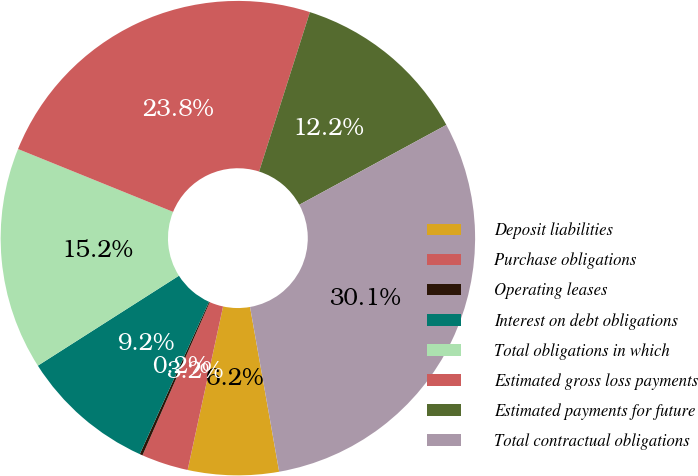Convert chart to OTSL. <chart><loc_0><loc_0><loc_500><loc_500><pie_chart><fcel>Deposit liabilities<fcel>Purchase obligations<fcel>Operating leases<fcel>Interest on debt obligations<fcel>Total obligations in which<fcel>Estimated gross loss payments<fcel>Estimated payments for future<fcel>Total contractual obligations<nl><fcel>6.18%<fcel>3.19%<fcel>0.2%<fcel>9.18%<fcel>15.16%<fcel>23.78%<fcel>12.17%<fcel>30.13%<nl></chart> 